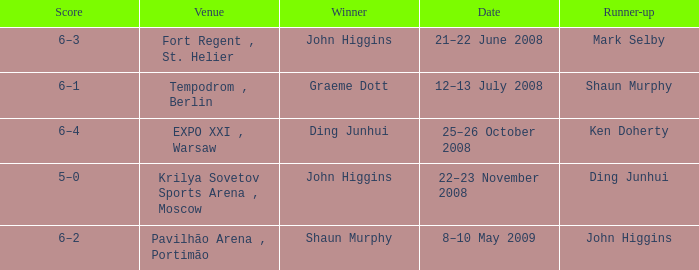Who was the winner in the match that had John Higgins as runner-up? Shaun Murphy. 